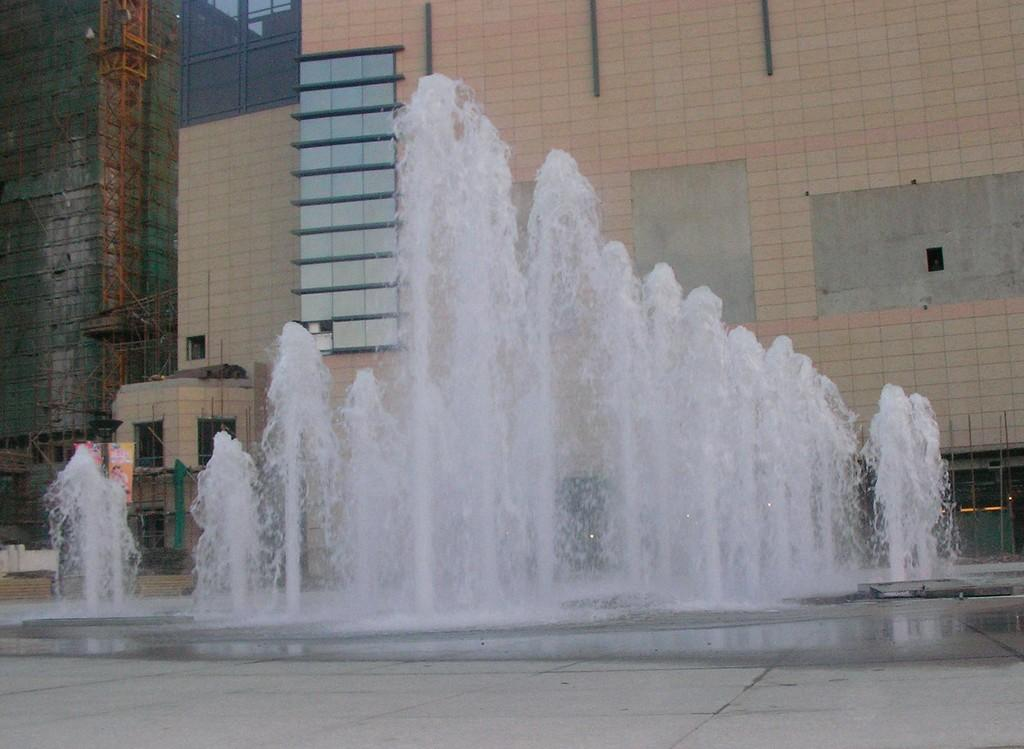What is the main feature in the image? There is a water fountain in the image. What can be seen behind the water fountain? There is a building behind the water fountain. Can you describe the construction of the building visible in the image? There is a construction of the building visible on the left side of the image. What type of pot is placed on the wall in the image? There is no pot placed on the wall in the image. 